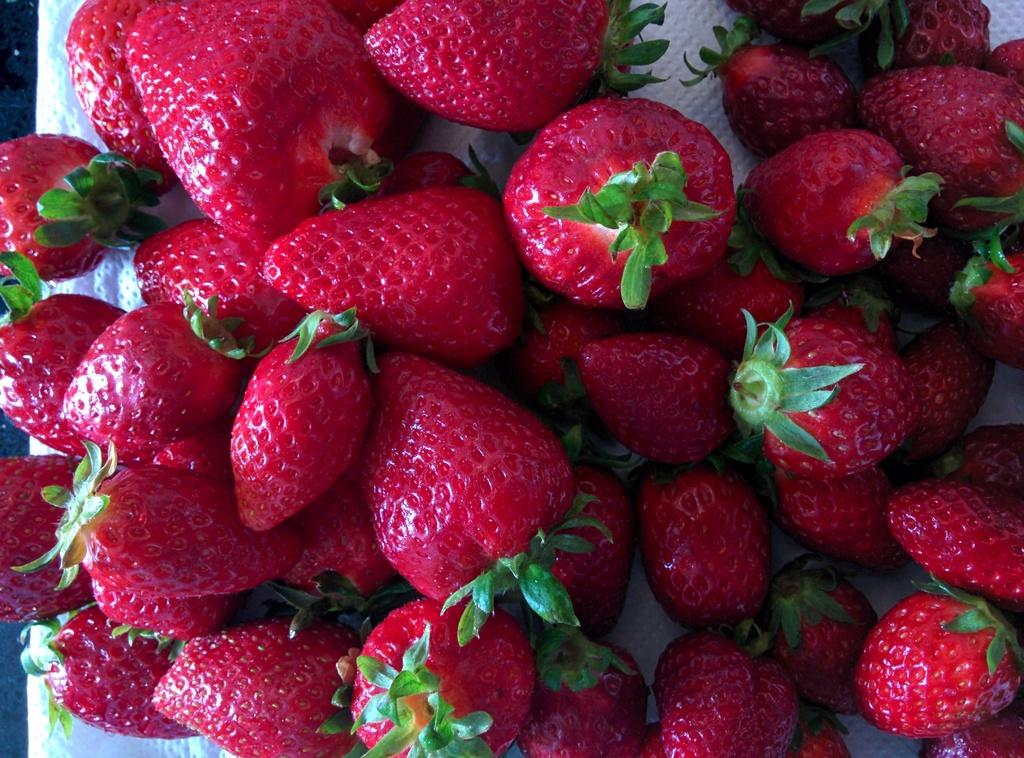What type of fruit is present in the image? There are strawberries in the image. What is the color of the strawberries? The color of the strawberries is not mentioned in the facts, so we cannot determine their color from the information provided. On what object are the strawberries placed? The strawberries are on a white object. How many cows are visible in the image? There are no cows present in the image; it only features strawberries on a white object. What type of kitchen appliance is visible in the image? There is no kitchen appliance mentioned in the facts, so we cannot determine if any are present in the image. 